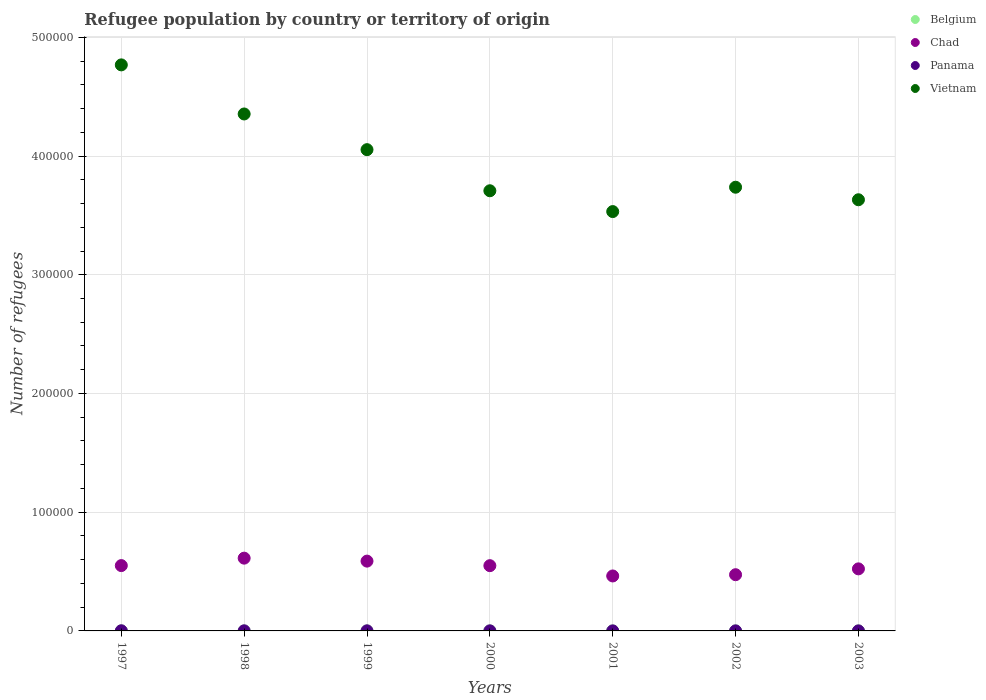How many different coloured dotlines are there?
Offer a terse response. 4. Is the number of dotlines equal to the number of legend labels?
Your answer should be very brief. Yes. Across all years, what is the maximum number of refugees in Vietnam?
Give a very brief answer. 4.77e+05. Across all years, what is the minimum number of refugees in Belgium?
Your response must be concise. 10. In which year was the number of refugees in Belgium maximum?
Give a very brief answer. 2003. What is the total number of refugees in Panama in the graph?
Provide a succinct answer. 457. What is the difference between the number of refugees in Chad in 1997 and that in 1998?
Your answer should be compact. -6273. What is the difference between the number of refugees in Chad in 1998 and the number of refugees in Vietnam in 2000?
Ensure brevity in your answer.  -3.09e+05. What is the average number of refugees in Belgium per year?
Your answer should be compact. 19.86. In how many years, is the number of refugees in Chad greater than 80000?
Give a very brief answer. 0. What is the ratio of the number of refugees in Vietnam in 1998 to that in 2001?
Offer a terse response. 1.23. Is the number of refugees in Vietnam in 1997 less than that in 2003?
Your response must be concise. No. What is the difference between the highest and the lowest number of refugees in Vietnam?
Your answer should be compact. 1.24e+05. In how many years, is the number of refugees in Chad greater than the average number of refugees in Chad taken over all years?
Keep it short and to the point. 4. Is it the case that in every year, the sum of the number of refugees in Chad and number of refugees in Belgium  is greater than the sum of number of refugees in Vietnam and number of refugees in Panama?
Provide a short and direct response. Yes. Is it the case that in every year, the sum of the number of refugees in Panama and number of refugees in Belgium  is greater than the number of refugees in Chad?
Provide a short and direct response. No. Does the number of refugees in Vietnam monotonically increase over the years?
Your response must be concise. No. Is the number of refugees in Panama strictly less than the number of refugees in Vietnam over the years?
Give a very brief answer. Yes. What is the difference between two consecutive major ticks on the Y-axis?
Your response must be concise. 1.00e+05. Are the values on the major ticks of Y-axis written in scientific E-notation?
Keep it short and to the point. No. Does the graph contain grids?
Keep it short and to the point. Yes. Where does the legend appear in the graph?
Offer a very short reply. Top right. How many legend labels are there?
Make the answer very short. 4. How are the legend labels stacked?
Make the answer very short. Vertical. What is the title of the graph?
Make the answer very short. Refugee population by country or territory of origin. Does "Gambia, The" appear as one of the legend labels in the graph?
Your answer should be compact. No. What is the label or title of the Y-axis?
Your response must be concise. Number of refugees. What is the Number of refugees of Belgium in 1997?
Keep it short and to the point. 10. What is the Number of refugees of Chad in 1997?
Give a very brief answer. 5.50e+04. What is the Number of refugees of Panama in 1997?
Offer a terse response. 122. What is the Number of refugees of Vietnam in 1997?
Your answer should be compact. 4.77e+05. What is the Number of refugees in Chad in 1998?
Offer a terse response. 6.13e+04. What is the Number of refugees in Vietnam in 1998?
Offer a very short reply. 4.35e+05. What is the Number of refugees in Belgium in 1999?
Ensure brevity in your answer.  16. What is the Number of refugees in Chad in 1999?
Your answer should be very brief. 5.88e+04. What is the Number of refugees of Vietnam in 1999?
Your answer should be compact. 4.05e+05. What is the Number of refugees of Belgium in 2000?
Provide a succinct answer. 19. What is the Number of refugees of Chad in 2000?
Provide a short and direct response. 5.50e+04. What is the Number of refugees in Panama in 2000?
Keep it short and to the point. 67. What is the Number of refugees in Vietnam in 2000?
Give a very brief answer. 3.71e+05. What is the Number of refugees in Chad in 2001?
Make the answer very short. 4.63e+04. What is the Number of refugees in Panama in 2001?
Give a very brief answer. 37. What is the Number of refugees in Vietnam in 2001?
Keep it short and to the point. 3.53e+05. What is the Number of refugees of Belgium in 2002?
Your response must be concise. 27. What is the Number of refugees in Chad in 2002?
Give a very brief answer. 4.73e+04. What is the Number of refugees of Vietnam in 2002?
Your answer should be compact. 3.74e+05. What is the Number of refugees of Chad in 2003?
Keep it short and to the point. 5.23e+04. What is the Number of refugees in Panama in 2003?
Ensure brevity in your answer.  30. What is the Number of refugees of Vietnam in 2003?
Ensure brevity in your answer.  3.63e+05. Across all years, what is the maximum Number of refugees of Chad?
Give a very brief answer. 6.13e+04. Across all years, what is the maximum Number of refugees of Panama?
Your answer should be compact. 122. Across all years, what is the maximum Number of refugees of Vietnam?
Your response must be concise. 4.77e+05. Across all years, what is the minimum Number of refugees in Chad?
Provide a succinct answer. 4.63e+04. Across all years, what is the minimum Number of refugees in Vietnam?
Offer a very short reply. 3.53e+05. What is the total Number of refugees in Belgium in the graph?
Offer a terse response. 139. What is the total Number of refugees of Chad in the graph?
Your answer should be compact. 3.76e+05. What is the total Number of refugees of Panama in the graph?
Give a very brief answer. 457. What is the total Number of refugees of Vietnam in the graph?
Provide a succinct answer. 2.78e+06. What is the difference between the Number of refugees in Belgium in 1997 and that in 1998?
Your answer should be compact. -4. What is the difference between the Number of refugees in Chad in 1997 and that in 1998?
Give a very brief answer. -6273. What is the difference between the Number of refugees of Vietnam in 1997 and that in 1998?
Your response must be concise. 4.14e+04. What is the difference between the Number of refugees of Chad in 1997 and that in 1999?
Your answer should be compact. -3772. What is the difference between the Number of refugees of Panama in 1997 and that in 1999?
Provide a succinct answer. 50. What is the difference between the Number of refugees of Vietnam in 1997 and that in 1999?
Make the answer very short. 7.14e+04. What is the difference between the Number of refugees of Belgium in 1997 and that in 2000?
Ensure brevity in your answer.  -9. What is the difference between the Number of refugees of Chad in 1997 and that in 2000?
Offer a very short reply. 63. What is the difference between the Number of refugees of Vietnam in 1997 and that in 2000?
Provide a succinct answer. 1.06e+05. What is the difference between the Number of refugees in Belgium in 1997 and that in 2001?
Offer a very short reply. -3. What is the difference between the Number of refugees in Chad in 1997 and that in 2001?
Your answer should be very brief. 8731. What is the difference between the Number of refugees of Panama in 1997 and that in 2001?
Give a very brief answer. 85. What is the difference between the Number of refugees of Vietnam in 1997 and that in 2001?
Your response must be concise. 1.24e+05. What is the difference between the Number of refugees of Chad in 1997 and that in 2002?
Ensure brevity in your answer.  7676. What is the difference between the Number of refugees in Panama in 1997 and that in 2002?
Your response must be concise. 78. What is the difference between the Number of refugees of Vietnam in 1997 and that in 2002?
Provide a short and direct response. 1.03e+05. What is the difference between the Number of refugees of Belgium in 1997 and that in 2003?
Provide a short and direct response. -30. What is the difference between the Number of refugees of Chad in 1997 and that in 2003?
Your answer should be very brief. 2750. What is the difference between the Number of refugees of Panama in 1997 and that in 2003?
Keep it short and to the point. 92. What is the difference between the Number of refugees of Vietnam in 1997 and that in 2003?
Keep it short and to the point. 1.14e+05. What is the difference between the Number of refugees of Belgium in 1998 and that in 1999?
Provide a succinct answer. -2. What is the difference between the Number of refugees in Chad in 1998 and that in 1999?
Offer a terse response. 2501. What is the difference between the Number of refugees of Panama in 1998 and that in 1999?
Ensure brevity in your answer.  13. What is the difference between the Number of refugees in Vietnam in 1998 and that in 1999?
Offer a very short reply. 3.01e+04. What is the difference between the Number of refugees in Chad in 1998 and that in 2000?
Provide a succinct answer. 6336. What is the difference between the Number of refugees of Vietnam in 1998 and that in 2000?
Offer a very short reply. 6.47e+04. What is the difference between the Number of refugees of Chad in 1998 and that in 2001?
Provide a succinct answer. 1.50e+04. What is the difference between the Number of refugees in Vietnam in 1998 and that in 2001?
Provide a succinct answer. 8.22e+04. What is the difference between the Number of refugees in Belgium in 1998 and that in 2002?
Offer a very short reply. -13. What is the difference between the Number of refugees of Chad in 1998 and that in 2002?
Keep it short and to the point. 1.39e+04. What is the difference between the Number of refugees of Panama in 1998 and that in 2002?
Keep it short and to the point. 41. What is the difference between the Number of refugees of Vietnam in 1998 and that in 2002?
Your response must be concise. 6.17e+04. What is the difference between the Number of refugees in Belgium in 1998 and that in 2003?
Your response must be concise. -26. What is the difference between the Number of refugees of Chad in 1998 and that in 2003?
Provide a succinct answer. 9023. What is the difference between the Number of refugees in Panama in 1998 and that in 2003?
Provide a succinct answer. 55. What is the difference between the Number of refugees of Vietnam in 1998 and that in 2003?
Your answer should be compact. 7.23e+04. What is the difference between the Number of refugees of Chad in 1999 and that in 2000?
Your response must be concise. 3835. What is the difference between the Number of refugees in Panama in 1999 and that in 2000?
Give a very brief answer. 5. What is the difference between the Number of refugees in Vietnam in 1999 and that in 2000?
Keep it short and to the point. 3.46e+04. What is the difference between the Number of refugees of Chad in 1999 and that in 2001?
Offer a terse response. 1.25e+04. What is the difference between the Number of refugees in Vietnam in 1999 and that in 2001?
Your answer should be very brief. 5.22e+04. What is the difference between the Number of refugees of Chad in 1999 and that in 2002?
Provide a succinct answer. 1.14e+04. What is the difference between the Number of refugees in Panama in 1999 and that in 2002?
Provide a short and direct response. 28. What is the difference between the Number of refugees in Vietnam in 1999 and that in 2002?
Make the answer very short. 3.16e+04. What is the difference between the Number of refugees of Belgium in 1999 and that in 2003?
Your answer should be compact. -24. What is the difference between the Number of refugees of Chad in 1999 and that in 2003?
Provide a short and direct response. 6522. What is the difference between the Number of refugees in Vietnam in 1999 and that in 2003?
Provide a succinct answer. 4.22e+04. What is the difference between the Number of refugees of Chad in 2000 and that in 2001?
Offer a terse response. 8668. What is the difference between the Number of refugees of Vietnam in 2000 and that in 2001?
Your answer should be compact. 1.75e+04. What is the difference between the Number of refugees of Chad in 2000 and that in 2002?
Your answer should be compact. 7613. What is the difference between the Number of refugees of Panama in 2000 and that in 2002?
Provide a short and direct response. 23. What is the difference between the Number of refugees of Vietnam in 2000 and that in 2002?
Give a very brief answer. -2983. What is the difference between the Number of refugees of Chad in 2000 and that in 2003?
Provide a succinct answer. 2687. What is the difference between the Number of refugees in Vietnam in 2000 and that in 2003?
Make the answer very short. 7579. What is the difference between the Number of refugees of Chad in 2001 and that in 2002?
Offer a very short reply. -1055. What is the difference between the Number of refugees in Panama in 2001 and that in 2002?
Offer a very short reply. -7. What is the difference between the Number of refugees in Vietnam in 2001 and that in 2002?
Provide a succinct answer. -2.05e+04. What is the difference between the Number of refugees of Chad in 2001 and that in 2003?
Your answer should be compact. -5981. What is the difference between the Number of refugees of Vietnam in 2001 and that in 2003?
Provide a short and direct response. -9955. What is the difference between the Number of refugees of Belgium in 2002 and that in 2003?
Offer a terse response. -13. What is the difference between the Number of refugees of Chad in 2002 and that in 2003?
Provide a short and direct response. -4926. What is the difference between the Number of refugees of Panama in 2002 and that in 2003?
Your answer should be compact. 14. What is the difference between the Number of refugees of Vietnam in 2002 and that in 2003?
Provide a succinct answer. 1.06e+04. What is the difference between the Number of refugees in Belgium in 1997 and the Number of refugees in Chad in 1998?
Your answer should be very brief. -6.13e+04. What is the difference between the Number of refugees in Belgium in 1997 and the Number of refugees in Panama in 1998?
Your answer should be compact. -75. What is the difference between the Number of refugees in Belgium in 1997 and the Number of refugees in Vietnam in 1998?
Offer a very short reply. -4.35e+05. What is the difference between the Number of refugees in Chad in 1997 and the Number of refugees in Panama in 1998?
Provide a short and direct response. 5.49e+04. What is the difference between the Number of refugees of Chad in 1997 and the Number of refugees of Vietnam in 1998?
Your answer should be very brief. -3.80e+05. What is the difference between the Number of refugees of Panama in 1997 and the Number of refugees of Vietnam in 1998?
Your response must be concise. -4.35e+05. What is the difference between the Number of refugees of Belgium in 1997 and the Number of refugees of Chad in 1999?
Ensure brevity in your answer.  -5.88e+04. What is the difference between the Number of refugees in Belgium in 1997 and the Number of refugees in Panama in 1999?
Provide a short and direct response. -62. What is the difference between the Number of refugees in Belgium in 1997 and the Number of refugees in Vietnam in 1999?
Offer a very short reply. -4.05e+05. What is the difference between the Number of refugees in Chad in 1997 and the Number of refugees in Panama in 1999?
Offer a terse response. 5.50e+04. What is the difference between the Number of refugees in Chad in 1997 and the Number of refugees in Vietnam in 1999?
Your answer should be compact. -3.50e+05. What is the difference between the Number of refugees of Panama in 1997 and the Number of refugees of Vietnam in 1999?
Provide a short and direct response. -4.05e+05. What is the difference between the Number of refugees of Belgium in 1997 and the Number of refugees of Chad in 2000?
Offer a terse response. -5.50e+04. What is the difference between the Number of refugees of Belgium in 1997 and the Number of refugees of Panama in 2000?
Make the answer very short. -57. What is the difference between the Number of refugees of Belgium in 1997 and the Number of refugees of Vietnam in 2000?
Ensure brevity in your answer.  -3.71e+05. What is the difference between the Number of refugees of Chad in 1997 and the Number of refugees of Panama in 2000?
Ensure brevity in your answer.  5.50e+04. What is the difference between the Number of refugees in Chad in 1997 and the Number of refugees in Vietnam in 2000?
Your answer should be very brief. -3.16e+05. What is the difference between the Number of refugees in Panama in 1997 and the Number of refugees in Vietnam in 2000?
Your answer should be very brief. -3.71e+05. What is the difference between the Number of refugees in Belgium in 1997 and the Number of refugees in Chad in 2001?
Provide a short and direct response. -4.63e+04. What is the difference between the Number of refugees in Belgium in 1997 and the Number of refugees in Panama in 2001?
Your answer should be very brief. -27. What is the difference between the Number of refugees in Belgium in 1997 and the Number of refugees in Vietnam in 2001?
Ensure brevity in your answer.  -3.53e+05. What is the difference between the Number of refugees of Chad in 1997 and the Number of refugees of Panama in 2001?
Your answer should be very brief. 5.50e+04. What is the difference between the Number of refugees in Chad in 1997 and the Number of refugees in Vietnam in 2001?
Your answer should be very brief. -2.98e+05. What is the difference between the Number of refugees in Panama in 1997 and the Number of refugees in Vietnam in 2001?
Provide a succinct answer. -3.53e+05. What is the difference between the Number of refugees in Belgium in 1997 and the Number of refugees in Chad in 2002?
Make the answer very short. -4.73e+04. What is the difference between the Number of refugees in Belgium in 1997 and the Number of refugees in Panama in 2002?
Your response must be concise. -34. What is the difference between the Number of refugees in Belgium in 1997 and the Number of refugees in Vietnam in 2002?
Provide a short and direct response. -3.74e+05. What is the difference between the Number of refugees of Chad in 1997 and the Number of refugees of Panama in 2002?
Keep it short and to the point. 5.50e+04. What is the difference between the Number of refugees of Chad in 1997 and the Number of refugees of Vietnam in 2002?
Keep it short and to the point. -3.19e+05. What is the difference between the Number of refugees of Panama in 1997 and the Number of refugees of Vietnam in 2002?
Your answer should be compact. -3.74e+05. What is the difference between the Number of refugees of Belgium in 1997 and the Number of refugees of Chad in 2003?
Offer a very short reply. -5.23e+04. What is the difference between the Number of refugees in Belgium in 1997 and the Number of refugees in Panama in 2003?
Provide a succinct answer. -20. What is the difference between the Number of refugees of Belgium in 1997 and the Number of refugees of Vietnam in 2003?
Provide a succinct answer. -3.63e+05. What is the difference between the Number of refugees in Chad in 1997 and the Number of refugees in Panama in 2003?
Your response must be concise. 5.50e+04. What is the difference between the Number of refugees in Chad in 1997 and the Number of refugees in Vietnam in 2003?
Ensure brevity in your answer.  -3.08e+05. What is the difference between the Number of refugees of Panama in 1997 and the Number of refugees of Vietnam in 2003?
Make the answer very short. -3.63e+05. What is the difference between the Number of refugees of Belgium in 1998 and the Number of refugees of Chad in 1999?
Give a very brief answer. -5.88e+04. What is the difference between the Number of refugees in Belgium in 1998 and the Number of refugees in Panama in 1999?
Provide a short and direct response. -58. What is the difference between the Number of refugees in Belgium in 1998 and the Number of refugees in Vietnam in 1999?
Offer a very short reply. -4.05e+05. What is the difference between the Number of refugees in Chad in 1998 and the Number of refugees in Panama in 1999?
Your answer should be very brief. 6.12e+04. What is the difference between the Number of refugees in Chad in 1998 and the Number of refugees in Vietnam in 1999?
Make the answer very short. -3.44e+05. What is the difference between the Number of refugees in Panama in 1998 and the Number of refugees in Vietnam in 1999?
Make the answer very short. -4.05e+05. What is the difference between the Number of refugees of Belgium in 1998 and the Number of refugees of Chad in 2000?
Provide a short and direct response. -5.49e+04. What is the difference between the Number of refugees in Belgium in 1998 and the Number of refugees in Panama in 2000?
Offer a very short reply. -53. What is the difference between the Number of refugees in Belgium in 1998 and the Number of refugees in Vietnam in 2000?
Offer a very short reply. -3.71e+05. What is the difference between the Number of refugees in Chad in 1998 and the Number of refugees in Panama in 2000?
Your answer should be compact. 6.12e+04. What is the difference between the Number of refugees of Chad in 1998 and the Number of refugees of Vietnam in 2000?
Offer a terse response. -3.09e+05. What is the difference between the Number of refugees in Panama in 1998 and the Number of refugees in Vietnam in 2000?
Your answer should be compact. -3.71e+05. What is the difference between the Number of refugees of Belgium in 1998 and the Number of refugees of Chad in 2001?
Offer a very short reply. -4.63e+04. What is the difference between the Number of refugees in Belgium in 1998 and the Number of refugees in Vietnam in 2001?
Offer a terse response. -3.53e+05. What is the difference between the Number of refugees in Chad in 1998 and the Number of refugees in Panama in 2001?
Your answer should be compact. 6.13e+04. What is the difference between the Number of refugees in Chad in 1998 and the Number of refugees in Vietnam in 2001?
Keep it short and to the point. -2.92e+05. What is the difference between the Number of refugees in Panama in 1998 and the Number of refugees in Vietnam in 2001?
Your answer should be very brief. -3.53e+05. What is the difference between the Number of refugees of Belgium in 1998 and the Number of refugees of Chad in 2002?
Ensure brevity in your answer.  -4.73e+04. What is the difference between the Number of refugees of Belgium in 1998 and the Number of refugees of Panama in 2002?
Your answer should be compact. -30. What is the difference between the Number of refugees in Belgium in 1998 and the Number of refugees in Vietnam in 2002?
Offer a terse response. -3.74e+05. What is the difference between the Number of refugees in Chad in 1998 and the Number of refugees in Panama in 2002?
Your answer should be very brief. 6.13e+04. What is the difference between the Number of refugees of Chad in 1998 and the Number of refugees of Vietnam in 2002?
Make the answer very short. -3.12e+05. What is the difference between the Number of refugees in Panama in 1998 and the Number of refugees in Vietnam in 2002?
Make the answer very short. -3.74e+05. What is the difference between the Number of refugees of Belgium in 1998 and the Number of refugees of Chad in 2003?
Your answer should be compact. -5.23e+04. What is the difference between the Number of refugees of Belgium in 1998 and the Number of refugees of Vietnam in 2003?
Offer a terse response. -3.63e+05. What is the difference between the Number of refugees in Chad in 1998 and the Number of refugees in Panama in 2003?
Provide a short and direct response. 6.13e+04. What is the difference between the Number of refugees in Chad in 1998 and the Number of refugees in Vietnam in 2003?
Make the answer very short. -3.02e+05. What is the difference between the Number of refugees in Panama in 1998 and the Number of refugees in Vietnam in 2003?
Offer a terse response. -3.63e+05. What is the difference between the Number of refugees in Belgium in 1999 and the Number of refugees in Chad in 2000?
Offer a very short reply. -5.49e+04. What is the difference between the Number of refugees of Belgium in 1999 and the Number of refugees of Panama in 2000?
Your answer should be very brief. -51. What is the difference between the Number of refugees of Belgium in 1999 and the Number of refugees of Vietnam in 2000?
Your answer should be very brief. -3.71e+05. What is the difference between the Number of refugees of Chad in 1999 and the Number of refugees of Panama in 2000?
Make the answer very short. 5.87e+04. What is the difference between the Number of refugees of Chad in 1999 and the Number of refugees of Vietnam in 2000?
Your response must be concise. -3.12e+05. What is the difference between the Number of refugees of Panama in 1999 and the Number of refugees of Vietnam in 2000?
Your answer should be very brief. -3.71e+05. What is the difference between the Number of refugees of Belgium in 1999 and the Number of refugees of Chad in 2001?
Ensure brevity in your answer.  -4.63e+04. What is the difference between the Number of refugees of Belgium in 1999 and the Number of refugees of Panama in 2001?
Offer a very short reply. -21. What is the difference between the Number of refugees in Belgium in 1999 and the Number of refugees in Vietnam in 2001?
Offer a very short reply. -3.53e+05. What is the difference between the Number of refugees in Chad in 1999 and the Number of refugees in Panama in 2001?
Give a very brief answer. 5.88e+04. What is the difference between the Number of refugees in Chad in 1999 and the Number of refugees in Vietnam in 2001?
Give a very brief answer. -2.94e+05. What is the difference between the Number of refugees of Panama in 1999 and the Number of refugees of Vietnam in 2001?
Your answer should be very brief. -3.53e+05. What is the difference between the Number of refugees in Belgium in 1999 and the Number of refugees in Chad in 2002?
Provide a succinct answer. -4.73e+04. What is the difference between the Number of refugees in Belgium in 1999 and the Number of refugees in Vietnam in 2002?
Your response must be concise. -3.74e+05. What is the difference between the Number of refugees in Chad in 1999 and the Number of refugees in Panama in 2002?
Provide a short and direct response. 5.88e+04. What is the difference between the Number of refugees in Chad in 1999 and the Number of refugees in Vietnam in 2002?
Offer a very short reply. -3.15e+05. What is the difference between the Number of refugees in Panama in 1999 and the Number of refugees in Vietnam in 2002?
Keep it short and to the point. -3.74e+05. What is the difference between the Number of refugees in Belgium in 1999 and the Number of refugees in Chad in 2003?
Your response must be concise. -5.23e+04. What is the difference between the Number of refugees of Belgium in 1999 and the Number of refugees of Vietnam in 2003?
Provide a short and direct response. -3.63e+05. What is the difference between the Number of refugees in Chad in 1999 and the Number of refugees in Panama in 2003?
Make the answer very short. 5.88e+04. What is the difference between the Number of refugees of Chad in 1999 and the Number of refugees of Vietnam in 2003?
Your answer should be compact. -3.04e+05. What is the difference between the Number of refugees in Panama in 1999 and the Number of refugees in Vietnam in 2003?
Give a very brief answer. -3.63e+05. What is the difference between the Number of refugees in Belgium in 2000 and the Number of refugees in Chad in 2001?
Your response must be concise. -4.63e+04. What is the difference between the Number of refugees in Belgium in 2000 and the Number of refugees in Vietnam in 2001?
Keep it short and to the point. -3.53e+05. What is the difference between the Number of refugees in Chad in 2000 and the Number of refugees in Panama in 2001?
Offer a terse response. 5.49e+04. What is the difference between the Number of refugees in Chad in 2000 and the Number of refugees in Vietnam in 2001?
Ensure brevity in your answer.  -2.98e+05. What is the difference between the Number of refugees of Panama in 2000 and the Number of refugees of Vietnam in 2001?
Offer a very short reply. -3.53e+05. What is the difference between the Number of refugees in Belgium in 2000 and the Number of refugees in Chad in 2002?
Make the answer very short. -4.73e+04. What is the difference between the Number of refugees in Belgium in 2000 and the Number of refugees in Vietnam in 2002?
Your answer should be compact. -3.74e+05. What is the difference between the Number of refugees of Chad in 2000 and the Number of refugees of Panama in 2002?
Provide a succinct answer. 5.49e+04. What is the difference between the Number of refugees of Chad in 2000 and the Number of refugees of Vietnam in 2002?
Offer a very short reply. -3.19e+05. What is the difference between the Number of refugees in Panama in 2000 and the Number of refugees in Vietnam in 2002?
Offer a terse response. -3.74e+05. What is the difference between the Number of refugees in Belgium in 2000 and the Number of refugees in Chad in 2003?
Your response must be concise. -5.23e+04. What is the difference between the Number of refugees in Belgium in 2000 and the Number of refugees in Vietnam in 2003?
Give a very brief answer. -3.63e+05. What is the difference between the Number of refugees in Chad in 2000 and the Number of refugees in Panama in 2003?
Your response must be concise. 5.49e+04. What is the difference between the Number of refugees in Chad in 2000 and the Number of refugees in Vietnam in 2003?
Offer a very short reply. -3.08e+05. What is the difference between the Number of refugees of Panama in 2000 and the Number of refugees of Vietnam in 2003?
Keep it short and to the point. -3.63e+05. What is the difference between the Number of refugees of Belgium in 2001 and the Number of refugees of Chad in 2002?
Ensure brevity in your answer.  -4.73e+04. What is the difference between the Number of refugees of Belgium in 2001 and the Number of refugees of Panama in 2002?
Your answer should be compact. -31. What is the difference between the Number of refugees of Belgium in 2001 and the Number of refugees of Vietnam in 2002?
Give a very brief answer. -3.74e+05. What is the difference between the Number of refugees in Chad in 2001 and the Number of refugees in Panama in 2002?
Offer a terse response. 4.62e+04. What is the difference between the Number of refugees in Chad in 2001 and the Number of refugees in Vietnam in 2002?
Keep it short and to the point. -3.27e+05. What is the difference between the Number of refugees in Panama in 2001 and the Number of refugees in Vietnam in 2002?
Your response must be concise. -3.74e+05. What is the difference between the Number of refugees in Belgium in 2001 and the Number of refugees in Chad in 2003?
Offer a very short reply. -5.23e+04. What is the difference between the Number of refugees of Belgium in 2001 and the Number of refugees of Vietnam in 2003?
Provide a short and direct response. -3.63e+05. What is the difference between the Number of refugees of Chad in 2001 and the Number of refugees of Panama in 2003?
Keep it short and to the point. 4.63e+04. What is the difference between the Number of refugees of Chad in 2001 and the Number of refugees of Vietnam in 2003?
Offer a very short reply. -3.17e+05. What is the difference between the Number of refugees of Panama in 2001 and the Number of refugees of Vietnam in 2003?
Provide a short and direct response. -3.63e+05. What is the difference between the Number of refugees in Belgium in 2002 and the Number of refugees in Chad in 2003?
Offer a terse response. -5.22e+04. What is the difference between the Number of refugees of Belgium in 2002 and the Number of refugees of Vietnam in 2003?
Ensure brevity in your answer.  -3.63e+05. What is the difference between the Number of refugees in Chad in 2002 and the Number of refugees in Panama in 2003?
Ensure brevity in your answer.  4.73e+04. What is the difference between the Number of refugees of Chad in 2002 and the Number of refugees of Vietnam in 2003?
Your answer should be compact. -3.16e+05. What is the difference between the Number of refugees in Panama in 2002 and the Number of refugees in Vietnam in 2003?
Give a very brief answer. -3.63e+05. What is the average Number of refugees in Belgium per year?
Provide a succinct answer. 19.86. What is the average Number of refugees in Chad per year?
Your response must be concise. 5.37e+04. What is the average Number of refugees in Panama per year?
Make the answer very short. 65.29. What is the average Number of refugees in Vietnam per year?
Give a very brief answer. 3.97e+05. In the year 1997, what is the difference between the Number of refugees in Belgium and Number of refugees in Chad?
Offer a very short reply. -5.50e+04. In the year 1997, what is the difference between the Number of refugees in Belgium and Number of refugees in Panama?
Offer a very short reply. -112. In the year 1997, what is the difference between the Number of refugees in Belgium and Number of refugees in Vietnam?
Provide a short and direct response. -4.77e+05. In the year 1997, what is the difference between the Number of refugees of Chad and Number of refugees of Panama?
Keep it short and to the point. 5.49e+04. In the year 1997, what is the difference between the Number of refugees in Chad and Number of refugees in Vietnam?
Ensure brevity in your answer.  -4.22e+05. In the year 1997, what is the difference between the Number of refugees of Panama and Number of refugees of Vietnam?
Offer a terse response. -4.77e+05. In the year 1998, what is the difference between the Number of refugees in Belgium and Number of refugees in Chad?
Ensure brevity in your answer.  -6.13e+04. In the year 1998, what is the difference between the Number of refugees of Belgium and Number of refugees of Panama?
Keep it short and to the point. -71. In the year 1998, what is the difference between the Number of refugees of Belgium and Number of refugees of Vietnam?
Ensure brevity in your answer.  -4.35e+05. In the year 1998, what is the difference between the Number of refugees of Chad and Number of refugees of Panama?
Give a very brief answer. 6.12e+04. In the year 1998, what is the difference between the Number of refugees of Chad and Number of refugees of Vietnam?
Provide a short and direct response. -3.74e+05. In the year 1998, what is the difference between the Number of refugees of Panama and Number of refugees of Vietnam?
Your answer should be very brief. -4.35e+05. In the year 1999, what is the difference between the Number of refugees of Belgium and Number of refugees of Chad?
Offer a terse response. -5.88e+04. In the year 1999, what is the difference between the Number of refugees of Belgium and Number of refugees of Panama?
Keep it short and to the point. -56. In the year 1999, what is the difference between the Number of refugees of Belgium and Number of refugees of Vietnam?
Provide a short and direct response. -4.05e+05. In the year 1999, what is the difference between the Number of refugees in Chad and Number of refugees in Panama?
Your answer should be compact. 5.87e+04. In the year 1999, what is the difference between the Number of refugees in Chad and Number of refugees in Vietnam?
Your answer should be very brief. -3.47e+05. In the year 1999, what is the difference between the Number of refugees in Panama and Number of refugees in Vietnam?
Make the answer very short. -4.05e+05. In the year 2000, what is the difference between the Number of refugees in Belgium and Number of refugees in Chad?
Make the answer very short. -5.49e+04. In the year 2000, what is the difference between the Number of refugees of Belgium and Number of refugees of Panama?
Ensure brevity in your answer.  -48. In the year 2000, what is the difference between the Number of refugees in Belgium and Number of refugees in Vietnam?
Keep it short and to the point. -3.71e+05. In the year 2000, what is the difference between the Number of refugees in Chad and Number of refugees in Panama?
Give a very brief answer. 5.49e+04. In the year 2000, what is the difference between the Number of refugees of Chad and Number of refugees of Vietnam?
Provide a succinct answer. -3.16e+05. In the year 2000, what is the difference between the Number of refugees of Panama and Number of refugees of Vietnam?
Keep it short and to the point. -3.71e+05. In the year 2001, what is the difference between the Number of refugees in Belgium and Number of refugees in Chad?
Offer a terse response. -4.63e+04. In the year 2001, what is the difference between the Number of refugees in Belgium and Number of refugees in Vietnam?
Provide a short and direct response. -3.53e+05. In the year 2001, what is the difference between the Number of refugees of Chad and Number of refugees of Panama?
Give a very brief answer. 4.63e+04. In the year 2001, what is the difference between the Number of refugees in Chad and Number of refugees in Vietnam?
Give a very brief answer. -3.07e+05. In the year 2001, what is the difference between the Number of refugees in Panama and Number of refugees in Vietnam?
Your response must be concise. -3.53e+05. In the year 2002, what is the difference between the Number of refugees in Belgium and Number of refugees in Chad?
Your response must be concise. -4.73e+04. In the year 2002, what is the difference between the Number of refugees of Belgium and Number of refugees of Vietnam?
Keep it short and to the point. -3.74e+05. In the year 2002, what is the difference between the Number of refugees in Chad and Number of refugees in Panama?
Your answer should be compact. 4.73e+04. In the year 2002, what is the difference between the Number of refugees of Chad and Number of refugees of Vietnam?
Provide a short and direct response. -3.26e+05. In the year 2002, what is the difference between the Number of refugees in Panama and Number of refugees in Vietnam?
Provide a succinct answer. -3.74e+05. In the year 2003, what is the difference between the Number of refugees of Belgium and Number of refugees of Chad?
Your answer should be very brief. -5.22e+04. In the year 2003, what is the difference between the Number of refugees of Belgium and Number of refugees of Panama?
Provide a succinct answer. 10. In the year 2003, what is the difference between the Number of refugees in Belgium and Number of refugees in Vietnam?
Make the answer very short. -3.63e+05. In the year 2003, what is the difference between the Number of refugees in Chad and Number of refugees in Panama?
Make the answer very short. 5.22e+04. In the year 2003, what is the difference between the Number of refugees of Chad and Number of refugees of Vietnam?
Offer a very short reply. -3.11e+05. In the year 2003, what is the difference between the Number of refugees of Panama and Number of refugees of Vietnam?
Offer a terse response. -3.63e+05. What is the ratio of the Number of refugees of Chad in 1997 to that in 1998?
Keep it short and to the point. 0.9. What is the ratio of the Number of refugees in Panama in 1997 to that in 1998?
Your response must be concise. 1.44. What is the ratio of the Number of refugees of Vietnam in 1997 to that in 1998?
Your answer should be very brief. 1.09. What is the ratio of the Number of refugees in Chad in 1997 to that in 1999?
Provide a short and direct response. 0.94. What is the ratio of the Number of refugees in Panama in 1997 to that in 1999?
Keep it short and to the point. 1.69. What is the ratio of the Number of refugees of Vietnam in 1997 to that in 1999?
Give a very brief answer. 1.18. What is the ratio of the Number of refugees of Belgium in 1997 to that in 2000?
Offer a very short reply. 0.53. What is the ratio of the Number of refugees in Chad in 1997 to that in 2000?
Provide a short and direct response. 1. What is the ratio of the Number of refugees in Panama in 1997 to that in 2000?
Provide a short and direct response. 1.82. What is the ratio of the Number of refugees of Vietnam in 1997 to that in 2000?
Your answer should be compact. 1.29. What is the ratio of the Number of refugees of Belgium in 1997 to that in 2001?
Offer a very short reply. 0.77. What is the ratio of the Number of refugees in Chad in 1997 to that in 2001?
Your response must be concise. 1.19. What is the ratio of the Number of refugees in Panama in 1997 to that in 2001?
Your answer should be very brief. 3.3. What is the ratio of the Number of refugees of Vietnam in 1997 to that in 2001?
Make the answer very short. 1.35. What is the ratio of the Number of refugees of Belgium in 1997 to that in 2002?
Provide a succinct answer. 0.37. What is the ratio of the Number of refugees in Chad in 1997 to that in 2002?
Give a very brief answer. 1.16. What is the ratio of the Number of refugees of Panama in 1997 to that in 2002?
Keep it short and to the point. 2.77. What is the ratio of the Number of refugees of Vietnam in 1997 to that in 2002?
Provide a short and direct response. 1.28. What is the ratio of the Number of refugees of Chad in 1997 to that in 2003?
Offer a terse response. 1.05. What is the ratio of the Number of refugees in Panama in 1997 to that in 2003?
Offer a terse response. 4.07. What is the ratio of the Number of refugees of Vietnam in 1997 to that in 2003?
Your answer should be very brief. 1.31. What is the ratio of the Number of refugees in Belgium in 1998 to that in 1999?
Your answer should be compact. 0.88. What is the ratio of the Number of refugees in Chad in 1998 to that in 1999?
Make the answer very short. 1.04. What is the ratio of the Number of refugees of Panama in 1998 to that in 1999?
Offer a very short reply. 1.18. What is the ratio of the Number of refugees of Vietnam in 1998 to that in 1999?
Your response must be concise. 1.07. What is the ratio of the Number of refugees in Belgium in 1998 to that in 2000?
Make the answer very short. 0.74. What is the ratio of the Number of refugees in Chad in 1998 to that in 2000?
Your answer should be very brief. 1.12. What is the ratio of the Number of refugees in Panama in 1998 to that in 2000?
Make the answer very short. 1.27. What is the ratio of the Number of refugees in Vietnam in 1998 to that in 2000?
Your answer should be compact. 1.17. What is the ratio of the Number of refugees in Chad in 1998 to that in 2001?
Your answer should be compact. 1.32. What is the ratio of the Number of refugees of Panama in 1998 to that in 2001?
Provide a succinct answer. 2.3. What is the ratio of the Number of refugees of Vietnam in 1998 to that in 2001?
Provide a short and direct response. 1.23. What is the ratio of the Number of refugees of Belgium in 1998 to that in 2002?
Your answer should be compact. 0.52. What is the ratio of the Number of refugees in Chad in 1998 to that in 2002?
Keep it short and to the point. 1.29. What is the ratio of the Number of refugees in Panama in 1998 to that in 2002?
Offer a terse response. 1.93. What is the ratio of the Number of refugees of Vietnam in 1998 to that in 2002?
Give a very brief answer. 1.17. What is the ratio of the Number of refugees in Chad in 1998 to that in 2003?
Your response must be concise. 1.17. What is the ratio of the Number of refugees in Panama in 1998 to that in 2003?
Your response must be concise. 2.83. What is the ratio of the Number of refugees in Vietnam in 1998 to that in 2003?
Give a very brief answer. 1.2. What is the ratio of the Number of refugees in Belgium in 1999 to that in 2000?
Provide a short and direct response. 0.84. What is the ratio of the Number of refugees of Chad in 1999 to that in 2000?
Keep it short and to the point. 1.07. What is the ratio of the Number of refugees in Panama in 1999 to that in 2000?
Provide a succinct answer. 1.07. What is the ratio of the Number of refugees in Vietnam in 1999 to that in 2000?
Offer a terse response. 1.09. What is the ratio of the Number of refugees of Belgium in 1999 to that in 2001?
Provide a short and direct response. 1.23. What is the ratio of the Number of refugees of Chad in 1999 to that in 2001?
Provide a succinct answer. 1.27. What is the ratio of the Number of refugees in Panama in 1999 to that in 2001?
Your answer should be very brief. 1.95. What is the ratio of the Number of refugees of Vietnam in 1999 to that in 2001?
Keep it short and to the point. 1.15. What is the ratio of the Number of refugees in Belgium in 1999 to that in 2002?
Provide a short and direct response. 0.59. What is the ratio of the Number of refugees in Chad in 1999 to that in 2002?
Your answer should be very brief. 1.24. What is the ratio of the Number of refugees of Panama in 1999 to that in 2002?
Keep it short and to the point. 1.64. What is the ratio of the Number of refugees of Vietnam in 1999 to that in 2002?
Ensure brevity in your answer.  1.08. What is the ratio of the Number of refugees in Belgium in 1999 to that in 2003?
Provide a short and direct response. 0.4. What is the ratio of the Number of refugees in Chad in 1999 to that in 2003?
Your answer should be compact. 1.12. What is the ratio of the Number of refugees of Panama in 1999 to that in 2003?
Your answer should be very brief. 2.4. What is the ratio of the Number of refugees in Vietnam in 1999 to that in 2003?
Ensure brevity in your answer.  1.12. What is the ratio of the Number of refugees of Belgium in 2000 to that in 2001?
Provide a succinct answer. 1.46. What is the ratio of the Number of refugees in Chad in 2000 to that in 2001?
Your answer should be compact. 1.19. What is the ratio of the Number of refugees in Panama in 2000 to that in 2001?
Your answer should be compact. 1.81. What is the ratio of the Number of refugees of Vietnam in 2000 to that in 2001?
Provide a succinct answer. 1.05. What is the ratio of the Number of refugees in Belgium in 2000 to that in 2002?
Give a very brief answer. 0.7. What is the ratio of the Number of refugees of Chad in 2000 to that in 2002?
Provide a succinct answer. 1.16. What is the ratio of the Number of refugees of Panama in 2000 to that in 2002?
Ensure brevity in your answer.  1.52. What is the ratio of the Number of refugees in Belgium in 2000 to that in 2003?
Keep it short and to the point. 0.47. What is the ratio of the Number of refugees of Chad in 2000 to that in 2003?
Give a very brief answer. 1.05. What is the ratio of the Number of refugees of Panama in 2000 to that in 2003?
Keep it short and to the point. 2.23. What is the ratio of the Number of refugees of Vietnam in 2000 to that in 2003?
Your answer should be compact. 1.02. What is the ratio of the Number of refugees of Belgium in 2001 to that in 2002?
Your answer should be very brief. 0.48. What is the ratio of the Number of refugees in Chad in 2001 to that in 2002?
Provide a short and direct response. 0.98. What is the ratio of the Number of refugees in Panama in 2001 to that in 2002?
Keep it short and to the point. 0.84. What is the ratio of the Number of refugees in Vietnam in 2001 to that in 2002?
Make the answer very short. 0.95. What is the ratio of the Number of refugees of Belgium in 2001 to that in 2003?
Make the answer very short. 0.33. What is the ratio of the Number of refugees of Chad in 2001 to that in 2003?
Give a very brief answer. 0.89. What is the ratio of the Number of refugees in Panama in 2001 to that in 2003?
Offer a very short reply. 1.23. What is the ratio of the Number of refugees in Vietnam in 2001 to that in 2003?
Provide a succinct answer. 0.97. What is the ratio of the Number of refugees of Belgium in 2002 to that in 2003?
Your answer should be very brief. 0.68. What is the ratio of the Number of refugees of Chad in 2002 to that in 2003?
Your answer should be very brief. 0.91. What is the ratio of the Number of refugees of Panama in 2002 to that in 2003?
Keep it short and to the point. 1.47. What is the ratio of the Number of refugees in Vietnam in 2002 to that in 2003?
Your answer should be very brief. 1.03. What is the difference between the highest and the second highest Number of refugees in Belgium?
Your answer should be very brief. 13. What is the difference between the highest and the second highest Number of refugees in Chad?
Make the answer very short. 2501. What is the difference between the highest and the second highest Number of refugees of Vietnam?
Offer a very short reply. 4.14e+04. What is the difference between the highest and the lowest Number of refugees of Chad?
Offer a terse response. 1.50e+04. What is the difference between the highest and the lowest Number of refugees of Panama?
Your answer should be very brief. 92. What is the difference between the highest and the lowest Number of refugees in Vietnam?
Provide a succinct answer. 1.24e+05. 